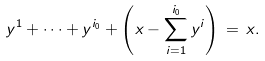<formula> <loc_0><loc_0><loc_500><loc_500>y ^ { 1 } + \dots + y ^ { i _ { 0 } } + \left ( x - \sum _ { i = 1 } ^ { i _ { 0 } } y ^ { i } \right ) \, = \, x .</formula> 